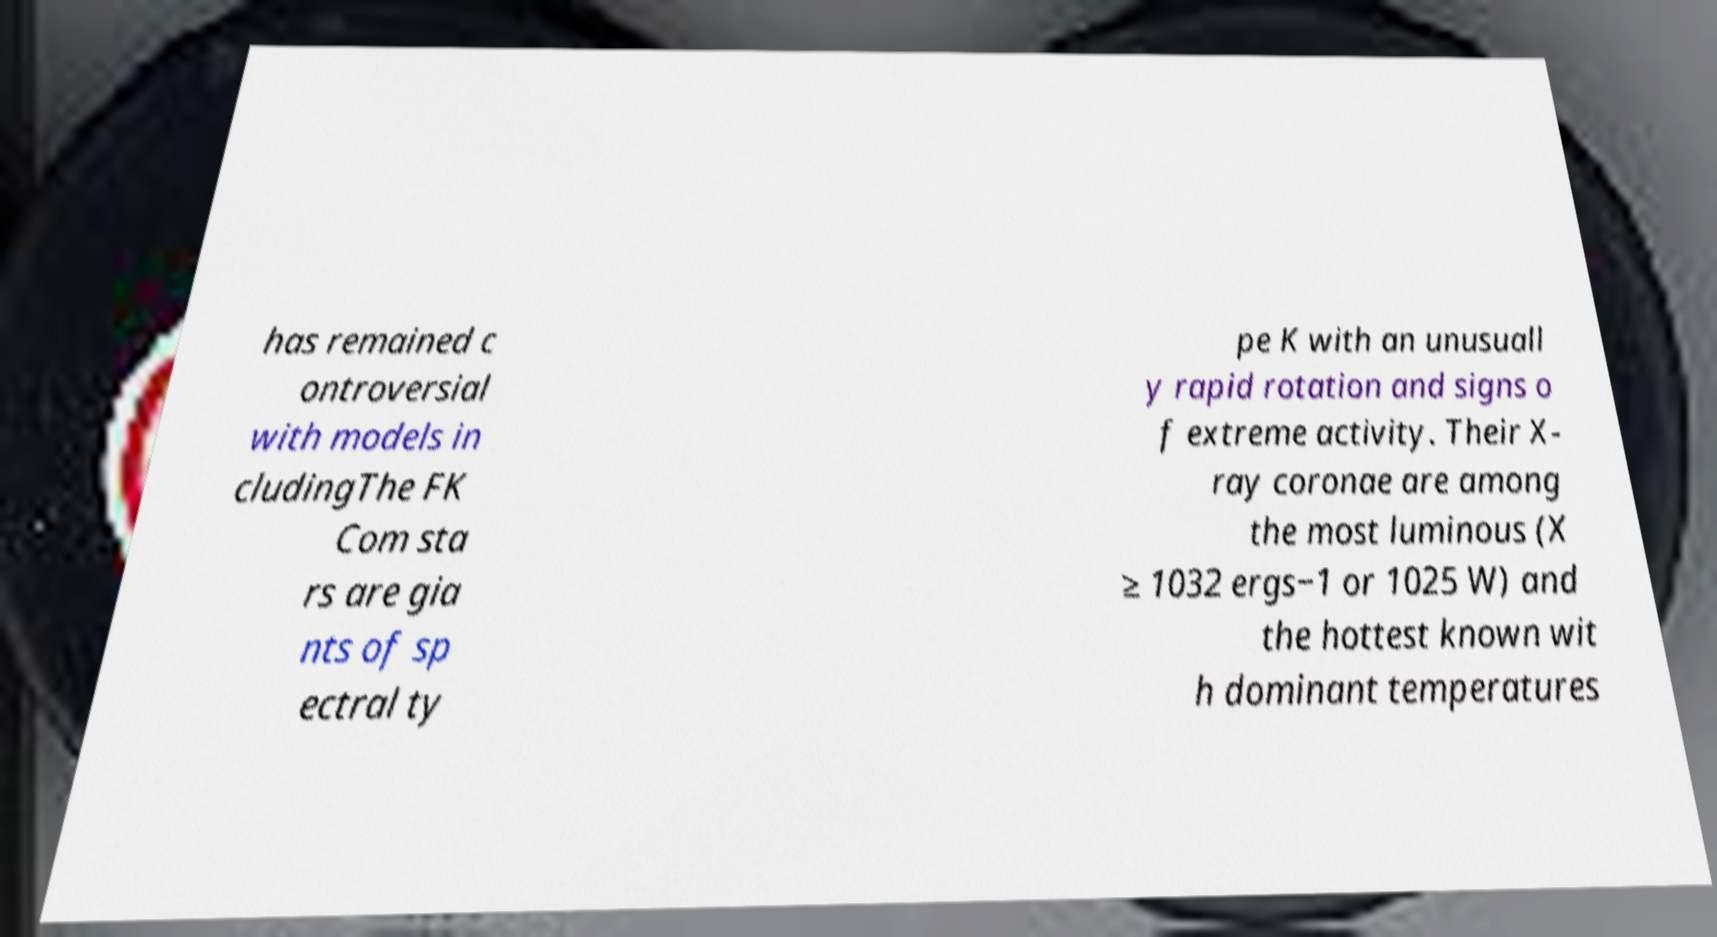Please read and relay the text visible in this image. What does it say? has remained c ontroversial with models in cludingThe FK Com sta rs are gia nts of sp ectral ty pe K with an unusuall y rapid rotation and signs o f extreme activity. Their X- ray coronae are among the most luminous (X ≥ 1032 ergs−1 or 1025 W) and the hottest known wit h dominant temperatures 